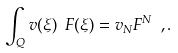Convert formula to latex. <formula><loc_0><loc_0><loc_500><loc_500>\int _ { Q } v ( \xi ) \ F ( \xi ) = v _ { N } F ^ { N } \ , .</formula> 